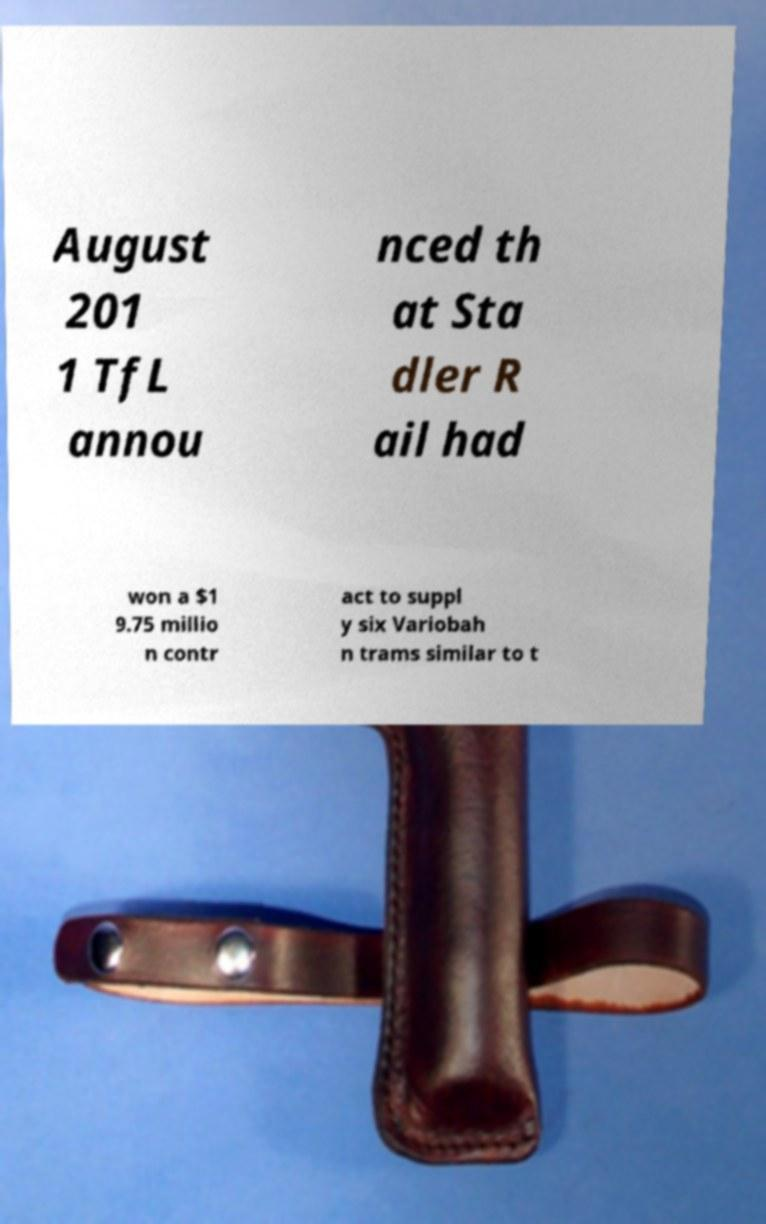There's text embedded in this image that I need extracted. Can you transcribe it verbatim? August 201 1 TfL annou nced th at Sta dler R ail had won a $1 9.75 millio n contr act to suppl y six Variobah n trams similar to t 